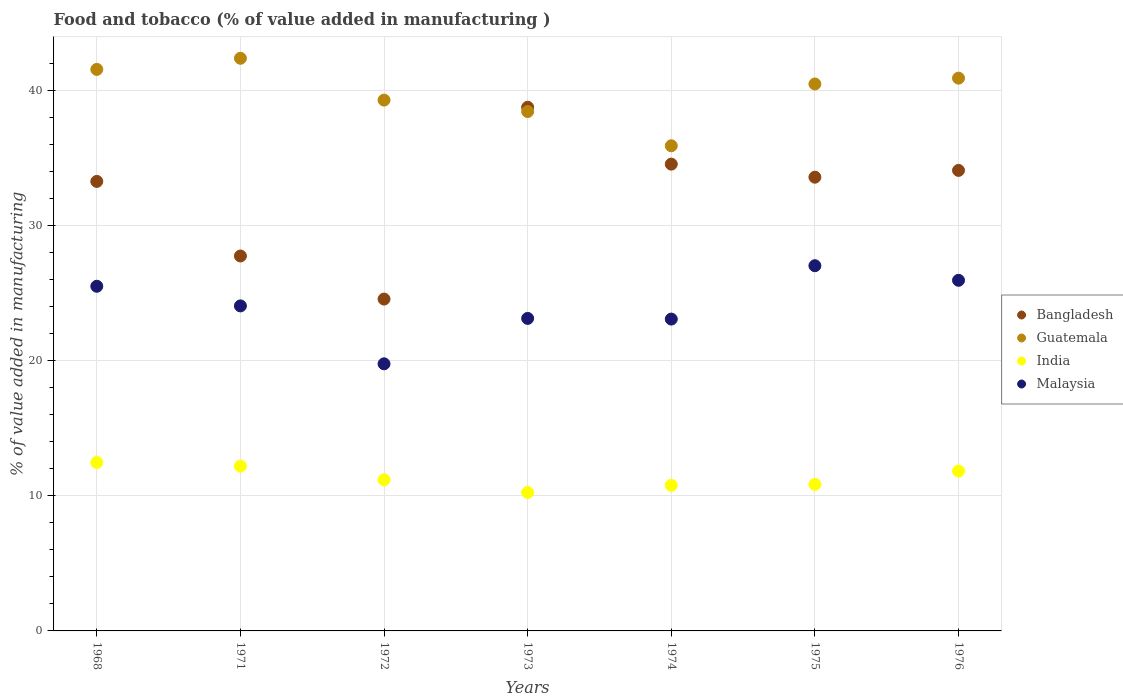Is the number of dotlines equal to the number of legend labels?
Offer a very short reply. Yes. What is the value added in manufacturing food and tobacco in Bangladesh in 1971?
Provide a short and direct response. 27.73. Across all years, what is the maximum value added in manufacturing food and tobacco in Malaysia?
Offer a terse response. 27.02. Across all years, what is the minimum value added in manufacturing food and tobacco in Bangladesh?
Provide a succinct answer. 24.55. In which year was the value added in manufacturing food and tobacco in Malaysia maximum?
Your response must be concise. 1975. What is the total value added in manufacturing food and tobacco in India in the graph?
Offer a terse response. 79.52. What is the difference between the value added in manufacturing food and tobacco in India in 1975 and that in 1976?
Ensure brevity in your answer.  -0.99. What is the difference between the value added in manufacturing food and tobacco in India in 1972 and the value added in manufacturing food and tobacco in Bangladesh in 1968?
Ensure brevity in your answer.  -22.07. What is the average value added in manufacturing food and tobacco in Malaysia per year?
Offer a very short reply. 24.06. In the year 1974, what is the difference between the value added in manufacturing food and tobacco in Bangladesh and value added in manufacturing food and tobacco in Malaysia?
Keep it short and to the point. 11.46. What is the ratio of the value added in manufacturing food and tobacco in Guatemala in 1973 to that in 1975?
Offer a very short reply. 0.95. What is the difference between the highest and the second highest value added in manufacturing food and tobacco in Malaysia?
Make the answer very short. 1.08. What is the difference between the highest and the lowest value added in manufacturing food and tobacco in Bangladesh?
Your answer should be very brief. 14.19. In how many years, is the value added in manufacturing food and tobacco in India greater than the average value added in manufacturing food and tobacco in India taken over all years?
Offer a terse response. 3. Is the value added in manufacturing food and tobacco in India strictly greater than the value added in manufacturing food and tobacco in Bangladesh over the years?
Your response must be concise. No. How many years are there in the graph?
Provide a short and direct response. 7. What is the difference between two consecutive major ticks on the Y-axis?
Make the answer very short. 10. How many legend labels are there?
Give a very brief answer. 4. What is the title of the graph?
Make the answer very short. Food and tobacco (% of value added in manufacturing ). Does "European Union" appear as one of the legend labels in the graph?
Your answer should be very brief. No. What is the label or title of the X-axis?
Your response must be concise. Years. What is the label or title of the Y-axis?
Make the answer very short. % of value added in manufacturing. What is the % of value added in manufacturing of Bangladesh in 1968?
Offer a very short reply. 33.25. What is the % of value added in manufacturing of Guatemala in 1968?
Make the answer very short. 41.54. What is the % of value added in manufacturing in India in 1968?
Offer a very short reply. 12.46. What is the % of value added in manufacturing of Malaysia in 1968?
Offer a very short reply. 25.49. What is the % of value added in manufacturing in Bangladesh in 1971?
Your response must be concise. 27.73. What is the % of value added in manufacturing of Guatemala in 1971?
Offer a very short reply. 42.36. What is the % of value added in manufacturing of India in 1971?
Your answer should be very brief. 12.19. What is the % of value added in manufacturing of Malaysia in 1971?
Make the answer very short. 24.04. What is the % of value added in manufacturing of Bangladesh in 1972?
Your answer should be very brief. 24.55. What is the % of value added in manufacturing of Guatemala in 1972?
Offer a very short reply. 39.27. What is the % of value added in manufacturing of India in 1972?
Make the answer very short. 11.18. What is the % of value added in manufacturing of Malaysia in 1972?
Provide a succinct answer. 19.76. What is the % of value added in manufacturing of Bangladesh in 1973?
Your answer should be very brief. 38.74. What is the % of value added in manufacturing of Guatemala in 1973?
Your answer should be very brief. 38.42. What is the % of value added in manufacturing of India in 1973?
Ensure brevity in your answer.  10.25. What is the % of value added in manufacturing in Malaysia in 1973?
Your answer should be compact. 23.12. What is the % of value added in manufacturing in Bangladesh in 1974?
Provide a succinct answer. 34.53. What is the % of value added in manufacturing of Guatemala in 1974?
Make the answer very short. 35.89. What is the % of value added in manufacturing in India in 1974?
Ensure brevity in your answer.  10.77. What is the % of value added in manufacturing of Malaysia in 1974?
Keep it short and to the point. 23.07. What is the % of value added in manufacturing of Bangladesh in 1975?
Your answer should be very brief. 33.56. What is the % of value added in manufacturing of Guatemala in 1975?
Your answer should be very brief. 40.46. What is the % of value added in manufacturing in India in 1975?
Offer a terse response. 10.84. What is the % of value added in manufacturing in Malaysia in 1975?
Your answer should be very brief. 27.02. What is the % of value added in manufacturing of Bangladesh in 1976?
Your response must be concise. 34.07. What is the % of value added in manufacturing in Guatemala in 1976?
Your response must be concise. 40.89. What is the % of value added in manufacturing of India in 1976?
Provide a succinct answer. 11.83. What is the % of value added in manufacturing of Malaysia in 1976?
Keep it short and to the point. 25.94. Across all years, what is the maximum % of value added in manufacturing in Bangladesh?
Ensure brevity in your answer.  38.74. Across all years, what is the maximum % of value added in manufacturing of Guatemala?
Ensure brevity in your answer.  42.36. Across all years, what is the maximum % of value added in manufacturing in India?
Offer a terse response. 12.46. Across all years, what is the maximum % of value added in manufacturing in Malaysia?
Keep it short and to the point. 27.02. Across all years, what is the minimum % of value added in manufacturing in Bangladesh?
Your answer should be compact. 24.55. Across all years, what is the minimum % of value added in manufacturing in Guatemala?
Provide a succinct answer. 35.89. Across all years, what is the minimum % of value added in manufacturing of India?
Ensure brevity in your answer.  10.25. Across all years, what is the minimum % of value added in manufacturing in Malaysia?
Give a very brief answer. 19.76. What is the total % of value added in manufacturing in Bangladesh in the graph?
Your answer should be very brief. 226.43. What is the total % of value added in manufacturing of Guatemala in the graph?
Offer a terse response. 278.82. What is the total % of value added in manufacturing in India in the graph?
Ensure brevity in your answer.  79.52. What is the total % of value added in manufacturing in Malaysia in the graph?
Offer a terse response. 168.43. What is the difference between the % of value added in manufacturing of Bangladesh in 1968 and that in 1971?
Your response must be concise. 5.52. What is the difference between the % of value added in manufacturing of Guatemala in 1968 and that in 1971?
Make the answer very short. -0.82. What is the difference between the % of value added in manufacturing in India in 1968 and that in 1971?
Make the answer very short. 0.27. What is the difference between the % of value added in manufacturing of Malaysia in 1968 and that in 1971?
Make the answer very short. 1.45. What is the difference between the % of value added in manufacturing of Bangladesh in 1968 and that in 1972?
Offer a very short reply. 8.7. What is the difference between the % of value added in manufacturing of Guatemala in 1968 and that in 1972?
Provide a short and direct response. 2.27. What is the difference between the % of value added in manufacturing in India in 1968 and that in 1972?
Give a very brief answer. 1.28. What is the difference between the % of value added in manufacturing in Malaysia in 1968 and that in 1972?
Offer a terse response. 5.74. What is the difference between the % of value added in manufacturing in Bangladesh in 1968 and that in 1973?
Offer a very short reply. -5.48. What is the difference between the % of value added in manufacturing in Guatemala in 1968 and that in 1973?
Provide a succinct answer. 3.12. What is the difference between the % of value added in manufacturing in India in 1968 and that in 1973?
Make the answer very short. 2.21. What is the difference between the % of value added in manufacturing in Malaysia in 1968 and that in 1973?
Give a very brief answer. 2.38. What is the difference between the % of value added in manufacturing of Bangladesh in 1968 and that in 1974?
Your answer should be compact. -1.28. What is the difference between the % of value added in manufacturing in Guatemala in 1968 and that in 1974?
Your response must be concise. 5.65. What is the difference between the % of value added in manufacturing of India in 1968 and that in 1974?
Ensure brevity in your answer.  1.69. What is the difference between the % of value added in manufacturing in Malaysia in 1968 and that in 1974?
Ensure brevity in your answer.  2.43. What is the difference between the % of value added in manufacturing in Bangladesh in 1968 and that in 1975?
Your answer should be very brief. -0.31. What is the difference between the % of value added in manufacturing of Guatemala in 1968 and that in 1975?
Provide a succinct answer. 1.08. What is the difference between the % of value added in manufacturing of India in 1968 and that in 1975?
Ensure brevity in your answer.  1.62. What is the difference between the % of value added in manufacturing in Malaysia in 1968 and that in 1975?
Provide a succinct answer. -1.52. What is the difference between the % of value added in manufacturing in Bangladesh in 1968 and that in 1976?
Offer a very short reply. -0.82. What is the difference between the % of value added in manufacturing in Guatemala in 1968 and that in 1976?
Your answer should be very brief. 0.65. What is the difference between the % of value added in manufacturing in India in 1968 and that in 1976?
Provide a short and direct response. 0.63. What is the difference between the % of value added in manufacturing of Malaysia in 1968 and that in 1976?
Offer a terse response. -0.44. What is the difference between the % of value added in manufacturing in Bangladesh in 1971 and that in 1972?
Your response must be concise. 3.19. What is the difference between the % of value added in manufacturing of Guatemala in 1971 and that in 1972?
Ensure brevity in your answer.  3.09. What is the difference between the % of value added in manufacturing of India in 1971 and that in 1972?
Your answer should be compact. 1.01. What is the difference between the % of value added in manufacturing in Malaysia in 1971 and that in 1972?
Your response must be concise. 4.28. What is the difference between the % of value added in manufacturing in Bangladesh in 1971 and that in 1973?
Make the answer very short. -11. What is the difference between the % of value added in manufacturing of Guatemala in 1971 and that in 1973?
Keep it short and to the point. 3.94. What is the difference between the % of value added in manufacturing in India in 1971 and that in 1973?
Keep it short and to the point. 1.95. What is the difference between the % of value added in manufacturing of Malaysia in 1971 and that in 1973?
Make the answer very short. 0.93. What is the difference between the % of value added in manufacturing in Bangladesh in 1971 and that in 1974?
Offer a terse response. -6.8. What is the difference between the % of value added in manufacturing in Guatemala in 1971 and that in 1974?
Provide a short and direct response. 6.47. What is the difference between the % of value added in manufacturing in India in 1971 and that in 1974?
Your answer should be very brief. 1.42. What is the difference between the % of value added in manufacturing of Malaysia in 1971 and that in 1974?
Keep it short and to the point. 0.97. What is the difference between the % of value added in manufacturing in Bangladesh in 1971 and that in 1975?
Provide a succinct answer. -5.83. What is the difference between the % of value added in manufacturing of Guatemala in 1971 and that in 1975?
Offer a very short reply. 1.9. What is the difference between the % of value added in manufacturing of India in 1971 and that in 1975?
Give a very brief answer. 1.35. What is the difference between the % of value added in manufacturing of Malaysia in 1971 and that in 1975?
Offer a very short reply. -2.97. What is the difference between the % of value added in manufacturing in Bangladesh in 1971 and that in 1976?
Provide a short and direct response. -6.33. What is the difference between the % of value added in manufacturing in Guatemala in 1971 and that in 1976?
Offer a very short reply. 1.47. What is the difference between the % of value added in manufacturing of India in 1971 and that in 1976?
Your answer should be compact. 0.37. What is the difference between the % of value added in manufacturing in Malaysia in 1971 and that in 1976?
Your answer should be very brief. -1.89. What is the difference between the % of value added in manufacturing of Bangladesh in 1972 and that in 1973?
Provide a succinct answer. -14.19. What is the difference between the % of value added in manufacturing in Guatemala in 1972 and that in 1973?
Ensure brevity in your answer.  0.85. What is the difference between the % of value added in manufacturing in India in 1972 and that in 1973?
Keep it short and to the point. 0.94. What is the difference between the % of value added in manufacturing of Malaysia in 1972 and that in 1973?
Your answer should be compact. -3.36. What is the difference between the % of value added in manufacturing in Bangladesh in 1972 and that in 1974?
Give a very brief answer. -9.98. What is the difference between the % of value added in manufacturing of Guatemala in 1972 and that in 1974?
Your answer should be very brief. 3.38. What is the difference between the % of value added in manufacturing of India in 1972 and that in 1974?
Provide a short and direct response. 0.41. What is the difference between the % of value added in manufacturing in Malaysia in 1972 and that in 1974?
Your answer should be compact. -3.31. What is the difference between the % of value added in manufacturing of Bangladesh in 1972 and that in 1975?
Give a very brief answer. -9.02. What is the difference between the % of value added in manufacturing in Guatemala in 1972 and that in 1975?
Provide a short and direct response. -1.19. What is the difference between the % of value added in manufacturing of India in 1972 and that in 1975?
Make the answer very short. 0.34. What is the difference between the % of value added in manufacturing in Malaysia in 1972 and that in 1975?
Offer a terse response. -7.26. What is the difference between the % of value added in manufacturing in Bangladesh in 1972 and that in 1976?
Keep it short and to the point. -9.52. What is the difference between the % of value added in manufacturing of Guatemala in 1972 and that in 1976?
Your response must be concise. -1.62. What is the difference between the % of value added in manufacturing of India in 1972 and that in 1976?
Provide a succinct answer. -0.65. What is the difference between the % of value added in manufacturing of Malaysia in 1972 and that in 1976?
Give a very brief answer. -6.18. What is the difference between the % of value added in manufacturing of Bangladesh in 1973 and that in 1974?
Ensure brevity in your answer.  4.21. What is the difference between the % of value added in manufacturing of Guatemala in 1973 and that in 1974?
Offer a very short reply. 2.53. What is the difference between the % of value added in manufacturing in India in 1973 and that in 1974?
Your answer should be compact. -0.52. What is the difference between the % of value added in manufacturing of Malaysia in 1973 and that in 1974?
Keep it short and to the point. 0.05. What is the difference between the % of value added in manufacturing of Bangladesh in 1973 and that in 1975?
Offer a very short reply. 5.17. What is the difference between the % of value added in manufacturing of Guatemala in 1973 and that in 1975?
Your answer should be very brief. -2.04. What is the difference between the % of value added in manufacturing of India in 1973 and that in 1975?
Give a very brief answer. -0.59. What is the difference between the % of value added in manufacturing in Malaysia in 1973 and that in 1975?
Provide a short and direct response. -3.9. What is the difference between the % of value added in manufacturing in Bangladesh in 1973 and that in 1976?
Offer a terse response. 4.67. What is the difference between the % of value added in manufacturing in Guatemala in 1973 and that in 1976?
Give a very brief answer. -2.47. What is the difference between the % of value added in manufacturing in India in 1973 and that in 1976?
Offer a terse response. -1.58. What is the difference between the % of value added in manufacturing in Malaysia in 1973 and that in 1976?
Provide a succinct answer. -2.82. What is the difference between the % of value added in manufacturing in Bangladesh in 1974 and that in 1975?
Ensure brevity in your answer.  0.97. What is the difference between the % of value added in manufacturing in Guatemala in 1974 and that in 1975?
Make the answer very short. -4.57. What is the difference between the % of value added in manufacturing of India in 1974 and that in 1975?
Provide a succinct answer. -0.07. What is the difference between the % of value added in manufacturing in Malaysia in 1974 and that in 1975?
Offer a terse response. -3.95. What is the difference between the % of value added in manufacturing of Bangladesh in 1974 and that in 1976?
Ensure brevity in your answer.  0.46. What is the difference between the % of value added in manufacturing in Guatemala in 1974 and that in 1976?
Give a very brief answer. -5. What is the difference between the % of value added in manufacturing in India in 1974 and that in 1976?
Your answer should be compact. -1.06. What is the difference between the % of value added in manufacturing in Malaysia in 1974 and that in 1976?
Offer a terse response. -2.87. What is the difference between the % of value added in manufacturing of Bangladesh in 1975 and that in 1976?
Your answer should be compact. -0.5. What is the difference between the % of value added in manufacturing in Guatemala in 1975 and that in 1976?
Your answer should be very brief. -0.43. What is the difference between the % of value added in manufacturing in India in 1975 and that in 1976?
Your answer should be compact. -0.99. What is the difference between the % of value added in manufacturing in Malaysia in 1975 and that in 1976?
Your answer should be compact. 1.08. What is the difference between the % of value added in manufacturing in Bangladesh in 1968 and the % of value added in manufacturing in Guatemala in 1971?
Offer a very short reply. -9.11. What is the difference between the % of value added in manufacturing in Bangladesh in 1968 and the % of value added in manufacturing in India in 1971?
Offer a very short reply. 21.06. What is the difference between the % of value added in manufacturing in Bangladesh in 1968 and the % of value added in manufacturing in Malaysia in 1971?
Your response must be concise. 9.21. What is the difference between the % of value added in manufacturing of Guatemala in 1968 and the % of value added in manufacturing of India in 1971?
Provide a short and direct response. 29.34. What is the difference between the % of value added in manufacturing in Guatemala in 1968 and the % of value added in manufacturing in Malaysia in 1971?
Offer a terse response. 17.49. What is the difference between the % of value added in manufacturing of India in 1968 and the % of value added in manufacturing of Malaysia in 1971?
Your answer should be compact. -11.58. What is the difference between the % of value added in manufacturing of Bangladesh in 1968 and the % of value added in manufacturing of Guatemala in 1972?
Provide a short and direct response. -6.01. What is the difference between the % of value added in manufacturing of Bangladesh in 1968 and the % of value added in manufacturing of India in 1972?
Make the answer very short. 22.07. What is the difference between the % of value added in manufacturing in Bangladesh in 1968 and the % of value added in manufacturing in Malaysia in 1972?
Offer a very short reply. 13.49. What is the difference between the % of value added in manufacturing of Guatemala in 1968 and the % of value added in manufacturing of India in 1972?
Your answer should be compact. 30.36. What is the difference between the % of value added in manufacturing of Guatemala in 1968 and the % of value added in manufacturing of Malaysia in 1972?
Provide a succinct answer. 21.78. What is the difference between the % of value added in manufacturing of India in 1968 and the % of value added in manufacturing of Malaysia in 1972?
Offer a very short reply. -7.3. What is the difference between the % of value added in manufacturing in Bangladesh in 1968 and the % of value added in manufacturing in Guatemala in 1973?
Offer a terse response. -5.17. What is the difference between the % of value added in manufacturing of Bangladesh in 1968 and the % of value added in manufacturing of India in 1973?
Keep it short and to the point. 23.01. What is the difference between the % of value added in manufacturing of Bangladesh in 1968 and the % of value added in manufacturing of Malaysia in 1973?
Provide a succinct answer. 10.13. What is the difference between the % of value added in manufacturing of Guatemala in 1968 and the % of value added in manufacturing of India in 1973?
Provide a short and direct response. 31.29. What is the difference between the % of value added in manufacturing in Guatemala in 1968 and the % of value added in manufacturing in Malaysia in 1973?
Make the answer very short. 18.42. What is the difference between the % of value added in manufacturing in India in 1968 and the % of value added in manufacturing in Malaysia in 1973?
Provide a succinct answer. -10.66. What is the difference between the % of value added in manufacturing in Bangladesh in 1968 and the % of value added in manufacturing in Guatemala in 1974?
Your answer should be very brief. -2.64. What is the difference between the % of value added in manufacturing of Bangladesh in 1968 and the % of value added in manufacturing of India in 1974?
Give a very brief answer. 22.48. What is the difference between the % of value added in manufacturing of Bangladesh in 1968 and the % of value added in manufacturing of Malaysia in 1974?
Offer a very short reply. 10.18. What is the difference between the % of value added in manufacturing of Guatemala in 1968 and the % of value added in manufacturing of India in 1974?
Provide a short and direct response. 30.77. What is the difference between the % of value added in manufacturing of Guatemala in 1968 and the % of value added in manufacturing of Malaysia in 1974?
Offer a terse response. 18.47. What is the difference between the % of value added in manufacturing in India in 1968 and the % of value added in manufacturing in Malaysia in 1974?
Your response must be concise. -10.61. What is the difference between the % of value added in manufacturing in Bangladesh in 1968 and the % of value added in manufacturing in Guatemala in 1975?
Make the answer very short. -7.21. What is the difference between the % of value added in manufacturing in Bangladesh in 1968 and the % of value added in manufacturing in India in 1975?
Your response must be concise. 22.41. What is the difference between the % of value added in manufacturing of Bangladesh in 1968 and the % of value added in manufacturing of Malaysia in 1975?
Keep it short and to the point. 6.24. What is the difference between the % of value added in manufacturing in Guatemala in 1968 and the % of value added in manufacturing in India in 1975?
Provide a short and direct response. 30.7. What is the difference between the % of value added in manufacturing of Guatemala in 1968 and the % of value added in manufacturing of Malaysia in 1975?
Ensure brevity in your answer.  14.52. What is the difference between the % of value added in manufacturing of India in 1968 and the % of value added in manufacturing of Malaysia in 1975?
Your answer should be compact. -14.56. What is the difference between the % of value added in manufacturing in Bangladesh in 1968 and the % of value added in manufacturing in Guatemala in 1976?
Make the answer very short. -7.64. What is the difference between the % of value added in manufacturing in Bangladesh in 1968 and the % of value added in manufacturing in India in 1976?
Your response must be concise. 21.42. What is the difference between the % of value added in manufacturing of Bangladesh in 1968 and the % of value added in manufacturing of Malaysia in 1976?
Offer a very short reply. 7.31. What is the difference between the % of value added in manufacturing of Guatemala in 1968 and the % of value added in manufacturing of India in 1976?
Give a very brief answer. 29.71. What is the difference between the % of value added in manufacturing in Guatemala in 1968 and the % of value added in manufacturing in Malaysia in 1976?
Your answer should be very brief. 15.6. What is the difference between the % of value added in manufacturing in India in 1968 and the % of value added in manufacturing in Malaysia in 1976?
Provide a short and direct response. -13.48. What is the difference between the % of value added in manufacturing in Bangladesh in 1971 and the % of value added in manufacturing in Guatemala in 1972?
Offer a terse response. -11.53. What is the difference between the % of value added in manufacturing in Bangladesh in 1971 and the % of value added in manufacturing in India in 1972?
Ensure brevity in your answer.  16.55. What is the difference between the % of value added in manufacturing of Bangladesh in 1971 and the % of value added in manufacturing of Malaysia in 1972?
Ensure brevity in your answer.  7.98. What is the difference between the % of value added in manufacturing of Guatemala in 1971 and the % of value added in manufacturing of India in 1972?
Offer a very short reply. 31.18. What is the difference between the % of value added in manufacturing of Guatemala in 1971 and the % of value added in manufacturing of Malaysia in 1972?
Offer a terse response. 22.6. What is the difference between the % of value added in manufacturing of India in 1971 and the % of value added in manufacturing of Malaysia in 1972?
Provide a succinct answer. -7.57. What is the difference between the % of value added in manufacturing of Bangladesh in 1971 and the % of value added in manufacturing of Guatemala in 1973?
Offer a very short reply. -10.69. What is the difference between the % of value added in manufacturing in Bangladesh in 1971 and the % of value added in manufacturing in India in 1973?
Offer a very short reply. 17.49. What is the difference between the % of value added in manufacturing of Bangladesh in 1971 and the % of value added in manufacturing of Malaysia in 1973?
Give a very brief answer. 4.62. What is the difference between the % of value added in manufacturing of Guatemala in 1971 and the % of value added in manufacturing of India in 1973?
Ensure brevity in your answer.  32.11. What is the difference between the % of value added in manufacturing of Guatemala in 1971 and the % of value added in manufacturing of Malaysia in 1973?
Make the answer very short. 19.24. What is the difference between the % of value added in manufacturing of India in 1971 and the % of value added in manufacturing of Malaysia in 1973?
Give a very brief answer. -10.92. What is the difference between the % of value added in manufacturing in Bangladesh in 1971 and the % of value added in manufacturing in Guatemala in 1974?
Provide a short and direct response. -8.15. What is the difference between the % of value added in manufacturing in Bangladesh in 1971 and the % of value added in manufacturing in India in 1974?
Offer a terse response. 16.96. What is the difference between the % of value added in manufacturing in Bangladesh in 1971 and the % of value added in manufacturing in Malaysia in 1974?
Give a very brief answer. 4.67. What is the difference between the % of value added in manufacturing in Guatemala in 1971 and the % of value added in manufacturing in India in 1974?
Give a very brief answer. 31.59. What is the difference between the % of value added in manufacturing in Guatemala in 1971 and the % of value added in manufacturing in Malaysia in 1974?
Your response must be concise. 19.29. What is the difference between the % of value added in manufacturing in India in 1971 and the % of value added in manufacturing in Malaysia in 1974?
Your response must be concise. -10.88. What is the difference between the % of value added in manufacturing in Bangladesh in 1971 and the % of value added in manufacturing in Guatemala in 1975?
Offer a terse response. -12.72. What is the difference between the % of value added in manufacturing of Bangladesh in 1971 and the % of value added in manufacturing of India in 1975?
Keep it short and to the point. 16.89. What is the difference between the % of value added in manufacturing in Bangladesh in 1971 and the % of value added in manufacturing in Malaysia in 1975?
Give a very brief answer. 0.72. What is the difference between the % of value added in manufacturing in Guatemala in 1971 and the % of value added in manufacturing in India in 1975?
Give a very brief answer. 31.52. What is the difference between the % of value added in manufacturing of Guatemala in 1971 and the % of value added in manufacturing of Malaysia in 1975?
Provide a succinct answer. 15.34. What is the difference between the % of value added in manufacturing of India in 1971 and the % of value added in manufacturing of Malaysia in 1975?
Offer a terse response. -14.82. What is the difference between the % of value added in manufacturing of Bangladesh in 1971 and the % of value added in manufacturing of Guatemala in 1976?
Ensure brevity in your answer.  -13.16. What is the difference between the % of value added in manufacturing of Bangladesh in 1971 and the % of value added in manufacturing of India in 1976?
Offer a very short reply. 15.91. What is the difference between the % of value added in manufacturing in Bangladesh in 1971 and the % of value added in manufacturing in Malaysia in 1976?
Provide a short and direct response. 1.8. What is the difference between the % of value added in manufacturing in Guatemala in 1971 and the % of value added in manufacturing in India in 1976?
Give a very brief answer. 30.53. What is the difference between the % of value added in manufacturing of Guatemala in 1971 and the % of value added in manufacturing of Malaysia in 1976?
Your answer should be very brief. 16.42. What is the difference between the % of value added in manufacturing in India in 1971 and the % of value added in manufacturing in Malaysia in 1976?
Your answer should be compact. -13.74. What is the difference between the % of value added in manufacturing of Bangladesh in 1972 and the % of value added in manufacturing of Guatemala in 1973?
Ensure brevity in your answer.  -13.87. What is the difference between the % of value added in manufacturing of Bangladesh in 1972 and the % of value added in manufacturing of India in 1973?
Keep it short and to the point. 14.3. What is the difference between the % of value added in manufacturing in Bangladesh in 1972 and the % of value added in manufacturing in Malaysia in 1973?
Provide a succinct answer. 1.43. What is the difference between the % of value added in manufacturing in Guatemala in 1972 and the % of value added in manufacturing in India in 1973?
Your answer should be very brief. 29.02. What is the difference between the % of value added in manufacturing of Guatemala in 1972 and the % of value added in manufacturing of Malaysia in 1973?
Make the answer very short. 16.15. What is the difference between the % of value added in manufacturing of India in 1972 and the % of value added in manufacturing of Malaysia in 1973?
Your answer should be compact. -11.94. What is the difference between the % of value added in manufacturing in Bangladesh in 1972 and the % of value added in manufacturing in Guatemala in 1974?
Ensure brevity in your answer.  -11.34. What is the difference between the % of value added in manufacturing in Bangladesh in 1972 and the % of value added in manufacturing in India in 1974?
Offer a terse response. 13.78. What is the difference between the % of value added in manufacturing of Bangladesh in 1972 and the % of value added in manufacturing of Malaysia in 1974?
Make the answer very short. 1.48. What is the difference between the % of value added in manufacturing of Guatemala in 1972 and the % of value added in manufacturing of India in 1974?
Offer a very short reply. 28.5. What is the difference between the % of value added in manufacturing of Guatemala in 1972 and the % of value added in manufacturing of Malaysia in 1974?
Provide a short and direct response. 16.2. What is the difference between the % of value added in manufacturing of India in 1972 and the % of value added in manufacturing of Malaysia in 1974?
Provide a succinct answer. -11.89. What is the difference between the % of value added in manufacturing of Bangladesh in 1972 and the % of value added in manufacturing of Guatemala in 1975?
Your answer should be very brief. -15.91. What is the difference between the % of value added in manufacturing in Bangladesh in 1972 and the % of value added in manufacturing in India in 1975?
Make the answer very short. 13.71. What is the difference between the % of value added in manufacturing in Bangladesh in 1972 and the % of value added in manufacturing in Malaysia in 1975?
Your answer should be very brief. -2.47. What is the difference between the % of value added in manufacturing in Guatemala in 1972 and the % of value added in manufacturing in India in 1975?
Offer a terse response. 28.43. What is the difference between the % of value added in manufacturing in Guatemala in 1972 and the % of value added in manufacturing in Malaysia in 1975?
Give a very brief answer. 12.25. What is the difference between the % of value added in manufacturing of India in 1972 and the % of value added in manufacturing of Malaysia in 1975?
Your answer should be compact. -15.83. What is the difference between the % of value added in manufacturing in Bangladesh in 1972 and the % of value added in manufacturing in Guatemala in 1976?
Your response must be concise. -16.34. What is the difference between the % of value added in manufacturing in Bangladesh in 1972 and the % of value added in manufacturing in India in 1976?
Your response must be concise. 12.72. What is the difference between the % of value added in manufacturing of Bangladesh in 1972 and the % of value added in manufacturing of Malaysia in 1976?
Make the answer very short. -1.39. What is the difference between the % of value added in manufacturing in Guatemala in 1972 and the % of value added in manufacturing in India in 1976?
Your answer should be compact. 27.44. What is the difference between the % of value added in manufacturing in Guatemala in 1972 and the % of value added in manufacturing in Malaysia in 1976?
Make the answer very short. 13.33. What is the difference between the % of value added in manufacturing in India in 1972 and the % of value added in manufacturing in Malaysia in 1976?
Your response must be concise. -14.76. What is the difference between the % of value added in manufacturing in Bangladesh in 1973 and the % of value added in manufacturing in Guatemala in 1974?
Offer a very short reply. 2.85. What is the difference between the % of value added in manufacturing of Bangladesh in 1973 and the % of value added in manufacturing of India in 1974?
Offer a terse response. 27.96. What is the difference between the % of value added in manufacturing of Bangladesh in 1973 and the % of value added in manufacturing of Malaysia in 1974?
Offer a very short reply. 15.67. What is the difference between the % of value added in manufacturing of Guatemala in 1973 and the % of value added in manufacturing of India in 1974?
Offer a terse response. 27.65. What is the difference between the % of value added in manufacturing in Guatemala in 1973 and the % of value added in manufacturing in Malaysia in 1974?
Offer a terse response. 15.35. What is the difference between the % of value added in manufacturing of India in 1973 and the % of value added in manufacturing of Malaysia in 1974?
Your answer should be compact. -12.82. What is the difference between the % of value added in manufacturing of Bangladesh in 1973 and the % of value added in manufacturing of Guatemala in 1975?
Your response must be concise. -1.72. What is the difference between the % of value added in manufacturing in Bangladesh in 1973 and the % of value added in manufacturing in India in 1975?
Offer a very short reply. 27.9. What is the difference between the % of value added in manufacturing of Bangladesh in 1973 and the % of value added in manufacturing of Malaysia in 1975?
Give a very brief answer. 11.72. What is the difference between the % of value added in manufacturing in Guatemala in 1973 and the % of value added in manufacturing in India in 1975?
Offer a very short reply. 27.58. What is the difference between the % of value added in manufacturing in Guatemala in 1973 and the % of value added in manufacturing in Malaysia in 1975?
Offer a very short reply. 11.4. What is the difference between the % of value added in manufacturing of India in 1973 and the % of value added in manufacturing of Malaysia in 1975?
Ensure brevity in your answer.  -16.77. What is the difference between the % of value added in manufacturing in Bangladesh in 1973 and the % of value added in manufacturing in Guatemala in 1976?
Provide a short and direct response. -2.15. What is the difference between the % of value added in manufacturing of Bangladesh in 1973 and the % of value added in manufacturing of India in 1976?
Give a very brief answer. 26.91. What is the difference between the % of value added in manufacturing in Bangladesh in 1973 and the % of value added in manufacturing in Malaysia in 1976?
Provide a short and direct response. 12.8. What is the difference between the % of value added in manufacturing in Guatemala in 1973 and the % of value added in manufacturing in India in 1976?
Make the answer very short. 26.59. What is the difference between the % of value added in manufacturing of Guatemala in 1973 and the % of value added in manufacturing of Malaysia in 1976?
Ensure brevity in your answer.  12.48. What is the difference between the % of value added in manufacturing of India in 1973 and the % of value added in manufacturing of Malaysia in 1976?
Offer a very short reply. -15.69. What is the difference between the % of value added in manufacturing of Bangladesh in 1974 and the % of value added in manufacturing of Guatemala in 1975?
Offer a terse response. -5.93. What is the difference between the % of value added in manufacturing of Bangladesh in 1974 and the % of value added in manufacturing of India in 1975?
Keep it short and to the point. 23.69. What is the difference between the % of value added in manufacturing of Bangladesh in 1974 and the % of value added in manufacturing of Malaysia in 1975?
Keep it short and to the point. 7.51. What is the difference between the % of value added in manufacturing in Guatemala in 1974 and the % of value added in manufacturing in India in 1975?
Your response must be concise. 25.05. What is the difference between the % of value added in manufacturing in Guatemala in 1974 and the % of value added in manufacturing in Malaysia in 1975?
Make the answer very short. 8.87. What is the difference between the % of value added in manufacturing in India in 1974 and the % of value added in manufacturing in Malaysia in 1975?
Give a very brief answer. -16.25. What is the difference between the % of value added in manufacturing of Bangladesh in 1974 and the % of value added in manufacturing of Guatemala in 1976?
Offer a terse response. -6.36. What is the difference between the % of value added in manufacturing of Bangladesh in 1974 and the % of value added in manufacturing of India in 1976?
Keep it short and to the point. 22.7. What is the difference between the % of value added in manufacturing in Bangladesh in 1974 and the % of value added in manufacturing in Malaysia in 1976?
Offer a terse response. 8.59. What is the difference between the % of value added in manufacturing in Guatemala in 1974 and the % of value added in manufacturing in India in 1976?
Give a very brief answer. 24.06. What is the difference between the % of value added in manufacturing of Guatemala in 1974 and the % of value added in manufacturing of Malaysia in 1976?
Provide a short and direct response. 9.95. What is the difference between the % of value added in manufacturing of India in 1974 and the % of value added in manufacturing of Malaysia in 1976?
Your answer should be very brief. -15.17. What is the difference between the % of value added in manufacturing of Bangladesh in 1975 and the % of value added in manufacturing of Guatemala in 1976?
Make the answer very short. -7.33. What is the difference between the % of value added in manufacturing of Bangladesh in 1975 and the % of value added in manufacturing of India in 1976?
Your response must be concise. 21.74. What is the difference between the % of value added in manufacturing in Bangladesh in 1975 and the % of value added in manufacturing in Malaysia in 1976?
Keep it short and to the point. 7.63. What is the difference between the % of value added in manufacturing of Guatemala in 1975 and the % of value added in manufacturing of India in 1976?
Your response must be concise. 28.63. What is the difference between the % of value added in manufacturing of Guatemala in 1975 and the % of value added in manufacturing of Malaysia in 1976?
Keep it short and to the point. 14.52. What is the difference between the % of value added in manufacturing in India in 1975 and the % of value added in manufacturing in Malaysia in 1976?
Your answer should be compact. -15.1. What is the average % of value added in manufacturing in Bangladesh per year?
Keep it short and to the point. 32.35. What is the average % of value added in manufacturing in Guatemala per year?
Provide a succinct answer. 39.83. What is the average % of value added in manufacturing in India per year?
Provide a succinct answer. 11.36. What is the average % of value added in manufacturing of Malaysia per year?
Make the answer very short. 24.06. In the year 1968, what is the difference between the % of value added in manufacturing of Bangladesh and % of value added in manufacturing of Guatemala?
Your response must be concise. -8.29. In the year 1968, what is the difference between the % of value added in manufacturing in Bangladesh and % of value added in manufacturing in India?
Your answer should be very brief. 20.79. In the year 1968, what is the difference between the % of value added in manufacturing of Bangladesh and % of value added in manufacturing of Malaysia?
Your response must be concise. 7.76. In the year 1968, what is the difference between the % of value added in manufacturing in Guatemala and % of value added in manufacturing in India?
Provide a short and direct response. 29.08. In the year 1968, what is the difference between the % of value added in manufacturing of Guatemala and % of value added in manufacturing of Malaysia?
Your answer should be compact. 16.04. In the year 1968, what is the difference between the % of value added in manufacturing in India and % of value added in manufacturing in Malaysia?
Ensure brevity in your answer.  -13.03. In the year 1971, what is the difference between the % of value added in manufacturing of Bangladesh and % of value added in manufacturing of Guatemala?
Your response must be concise. -14.63. In the year 1971, what is the difference between the % of value added in manufacturing in Bangladesh and % of value added in manufacturing in India?
Your answer should be compact. 15.54. In the year 1971, what is the difference between the % of value added in manufacturing in Bangladesh and % of value added in manufacturing in Malaysia?
Ensure brevity in your answer.  3.69. In the year 1971, what is the difference between the % of value added in manufacturing in Guatemala and % of value added in manufacturing in India?
Make the answer very short. 30.17. In the year 1971, what is the difference between the % of value added in manufacturing of Guatemala and % of value added in manufacturing of Malaysia?
Provide a succinct answer. 18.32. In the year 1971, what is the difference between the % of value added in manufacturing of India and % of value added in manufacturing of Malaysia?
Provide a short and direct response. -11.85. In the year 1972, what is the difference between the % of value added in manufacturing of Bangladesh and % of value added in manufacturing of Guatemala?
Keep it short and to the point. -14.72. In the year 1972, what is the difference between the % of value added in manufacturing in Bangladesh and % of value added in manufacturing in India?
Ensure brevity in your answer.  13.37. In the year 1972, what is the difference between the % of value added in manufacturing of Bangladesh and % of value added in manufacturing of Malaysia?
Provide a short and direct response. 4.79. In the year 1972, what is the difference between the % of value added in manufacturing in Guatemala and % of value added in manufacturing in India?
Offer a very short reply. 28.08. In the year 1972, what is the difference between the % of value added in manufacturing in Guatemala and % of value added in manufacturing in Malaysia?
Offer a very short reply. 19.51. In the year 1972, what is the difference between the % of value added in manufacturing in India and % of value added in manufacturing in Malaysia?
Your response must be concise. -8.58. In the year 1973, what is the difference between the % of value added in manufacturing of Bangladesh and % of value added in manufacturing of Guatemala?
Your answer should be compact. 0.31. In the year 1973, what is the difference between the % of value added in manufacturing of Bangladesh and % of value added in manufacturing of India?
Your response must be concise. 28.49. In the year 1973, what is the difference between the % of value added in manufacturing of Bangladesh and % of value added in manufacturing of Malaysia?
Make the answer very short. 15.62. In the year 1973, what is the difference between the % of value added in manufacturing in Guatemala and % of value added in manufacturing in India?
Ensure brevity in your answer.  28.18. In the year 1973, what is the difference between the % of value added in manufacturing in Guatemala and % of value added in manufacturing in Malaysia?
Give a very brief answer. 15.3. In the year 1973, what is the difference between the % of value added in manufacturing of India and % of value added in manufacturing of Malaysia?
Keep it short and to the point. -12.87. In the year 1974, what is the difference between the % of value added in manufacturing in Bangladesh and % of value added in manufacturing in Guatemala?
Your answer should be very brief. -1.36. In the year 1974, what is the difference between the % of value added in manufacturing of Bangladesh and % of value added in manufacturing of India?
Give a very brief answer. 23.76. In the year 1974, what is the difference between the % of value added in manufacturing in Bangladesh and % of value added in manufacturing in Malaysia?
Offer a very short reply. 11.46. In the year 1974, what is the difference between the % of value added in manufacturing of Guatemala and % of value added in manufacturing of India?
Offer a terse response. 25.12. In the year 1974, what is the difference between the % of value added in manufacturing of Guatemala and % of value added in manufacturing of Malaysia?
Keep it short and to the point. 12.82. In the year 1974, what is the difference between the % of value added in manufacturing in India and % of value added in manufacturing in Malaysia?
Provide a succinct answer. -12.3. In the year 1975, what is the difference between the % of value added in manufacturing in Bangladesh and % of value added in manufacturing in Guatemala?
Provide a short and direct response. -6.9. In the year 1975, what is the difference between the % of value added in manufacturing in Bangladesh and % of value added in manufacturing in India?
Offer a very short reply. 22.72. In the year 1975, what is the difference between the % of value added in manufacturing in Bangladesh and % of value added in manufacturing in Malaysia?
Your answer should be compact. 6.55. In the year 1975, what is the difference between the % of value added in manufacturing in Guatemala and % of value added in manufacturing in India?
Your answer should be compact. 29.62. In the year 1975, what is the difference between the % of value added in manufacturing in Guatemala and % of value added in manufacturing in Malaysia?
Offer a very short reply. 13.44. In the year 1975, what is the difference between the % of value added in manufacturing of India and % of value added in manufacturing of Malaysia?
Your response must be concise. -16.18. In the year 1976, what is the difference between the % of value added in manufacturing in Bangladesh and % of value added in manufacturing in Guatemala?
Your answer should be compact. -6.82. In the year 1976, what is the difference between the % of value added in manufacturing of Bangladesh and % of value added in manufacturing of India?
Provide a succinct answer. 22.24. In the year 1976, what is the difference between the % of value added in manufacturing in Bangladesh and % of value added in manufacturing in Malaysia?
Offer a very short reply. 8.13. In the year 1976, what is the difference between the % of value added in manufacturing of Guatemala and % of value added in manufacturing of India?
Your answer should be very brief. 29.06. In the year 1976, what is the difference between the % of value added in manufacturing of Guatemala and % of value added in manufacturing of Malaysia?
Offer a terse response. 14.95. In the year 1976, what is the difference between the % of value added in manufacturing in India and % of value added in manufacturing in Malaysia?
Keep it short and to the point. -14.11. What is the ratio of the % of value added in manufacturing of Bangladesh in 1968 to that in 1971?
Offer a terse response. 1.2. What is the ratio of the % of value added in manufacturing of Guatemala in 1968 to that in 1971?
Give a very brief answer. 0.98. What is the ratio of the % of value added in manufacturing of India in 1968 to that in 1971?
Make the answer very short. 1.02. What is the ratio of the % of value added in manufacturing of Malaysia in 1968 to that in 1971?
Offer a very short reply. 1.06. What is the ratio of the % of value added in manufacturing in Bangladesh in 1968 to that in 1972?
Offer a very short reply. 1.35. What is the ratio of the % of value added in manufacturing of Guatemala in 1968 to that in 1972?
Your answer should be very brief. 1.06. What is the ratio of the % of value added in manufacturing in India in 1968 to that in 1972?
Offer a terse response. 1.11. What is the ratio of the % of value added in manufacturing of Malaysia in 1968 to that in 1972?
Provide a succinct answer. 1.29. What is the ratio of the % of value added in manufacturing of Bangladesh in 1968 to that in 1973?
Offer a very short reply. 0.86. What is the ratio of the % of value added in manufacturing in Guatemala in 1968 to that in 1973?
Ensure brevity in your answer.  1.08. What is the ratio of the % of value added in manufacturing of India in 1968 to that in 1973?
Provide a short and direct response. 1.22. What is the ratio of the % of value added in manufacturing in Malaysia in 1968 to that in 1973?
Offer a very short reply. 1.1. What is the ratio of the % of value added in manufacturing of Guatemala in 1968 to that in 1974?
Offer a terse response. 1.16. What is the ratio of the % of value added in manufacturing of India in 1968 to that in 1974?
Your response must be concise. 1.16. What is the ratio of the % of value added in manufacturing in Malaysia in 1968 to that in 1974?
Keep it short and to the point. 1.11. What is the ratio of the % of value added in manufacturing of Bangladesh in 1968 to that in 1975?
Offer a terse response. 0.99. What is the ratio of the % of value added in manufacturing of Guatemala in 1968 to that in 1975?
Give a very brief answer. 1.03. What is the ratio of the % of value added in manufacturing of India in 1968 to that in 1975?
Provide a succinct answer. 1.15. What is the ratio of the % of value added in manufacturing in Malaysia in 1968 to that in 1975?
Provide a succinct answer. 0.94. What is the ratio of the % of value added in manufacturing in Bangladesh in 1968 to that in 1976?
Provide a short and direct response. 0.98. What is the ratio of the % of value added in manufacturing in Guatemala in 1968 to that in 1976?
Offer a very short reply. 1.02. What is the ratio of the % of value added in manufacturing of India in 1968 to that in 1976?
Your answer should be very brief. 1.05. What is the ratio of the % of value added in manufacturing in Bangladesh in 1971 to that in 1972?
Provide a succinct answer. 1.13. What is the ratio of the % of value added in manufacturing of Guatemala in 1971 to that in 1972?
Provide a succinct answer. 1.08. What is the ratio of the % of value added in manufacturing in India in 1971 to that in 1972?
Provide a succinct answer. 1.09. What is the ratio of the % of value added in manufacturing of Malaysia in 1971 to that in 1972?
Give a very brief answer. 1.22. What is the ratio of the % of value added in manufacturing in Bangladesh in 1971 to that in 1973?
Offer a very short reply. 0.72. What is the ratio of the % of value added in manufacturing in Guatemala in 1971 to that in 1973?
Provide a succinct answer. 1.1. What is the ratio of the % of value added in manufacturing of India in 1971 to that in 1973?
Offer a very short reply. 1.19. What is the ratio of the % of value added in manufacturing in Malaysia in 1971 to that in 1973?
Keep it short and to the point. 1.04. What is the ratio of the % of value added in manufacturing of Bangladesh in 1971 to that in 1974?
Provide a succinct answer. 0.8. What is the ratio of the % of value added in manufacturing in Guatemala in 1971 to that in 1974?
Your answer should be very brief. 1.18. What is the ratio of the % of value added in manufacturing of India in 1971 to that in 1974?
Provide a short and direct response. 1.13. What is the ratio of the % of value added in manufacturing of Malaysia in 1971 to that in 1974?
Your response must be concise. 1.04. What is the ratio of the % of value added in manufacturing of Bangladesh in 1971 to that in 1975?
Offer a very short reply. 0.83. What is the ratio of the % of value added in manufacturing of Guatemala in 1971 to that in 1975?
Give a very brief answer. 1.05. What is the ratio of the % of value added in manufacturing in India in 1971 to that in 1975?
Your answer should be very brief. 1.12. What is the ratio of the % of value added in manufacturing in Malaysia in 1971 to that in 1975?
Offer a very short reply. 0.89. What is the ratio of the % of value added in manufacturing in Bangladesh in 1971 to that in 1976?
Offer a terse response. 0.81. What is the ratio of the % of value added in manufacturing of Guatemala in 1971 to that in 1976?
Your response must be concise. 1.04. What is the ratio of the % of value added in manufacturing of India in 1971 to that in 1976?
Provide a short and direct response. 1.03. What is the ratio of the % of value added in manufacturing in Malaysia in 1971 to that in 1976?
Your answer should be very brief. 0.93. What is the ratio of the % of value added in manufacturing in Bangladesh in 1972 to that in 1973?
Make the answer very short. 0.63. What is the ratio of the % of value added in manufacturing of India in 1972 to that in 1973?
Provide a succinct answer. 1.09. What is the ratio of the % of value added in manufacturing in Malaysia in 1972 to that in 1973?
Your answer should be very brief. 0.85. What is the ratio of the % of value added in manufacturing of Bangladesh in 1972 to that in 1974?
Offer a very short reply. 0.71. What is the ratio of the % of value added in manufacturing of Guatemala in 1972 to that in 1974?
Make the answer very short. 1.09. What is the ratio of the % of value added in manufacturing in India in 1972 to that in 1974?
Your answer should be compact. 1.04. What is the ratio of the % of value added in manufacturing of Malaysia in 1972 to that in 1974?
Give a very brief answer. 0.86. What is the ratio of the % of value added in manufacturing of Bangladesh in 1972 to that in 1975?
Your answer should be very brief. 0.73. What is the ratio of the % of value added in manufacturing of Guatemala in 1972 to that in 1975?
Keep it short and to the point. 0.97. What is the ratio of the % of value added in manufacturing in India in 1972 to that in 1975?
Your answer should be compact. 1.03. What is the ratio of the % of value added in manufacturing in Malaysia in 1972 to that in 1975?
Ensure brevity in your answer.  0.73. What is the ratio of the % of value added in manufacturing in Bangladesh in 1972 to that in 1976?
Provide a succinct answer. 0.72. What is the ratio of the % of value added in manufacturing in Guatemala in 1972 to that in 1976?
Ensure brevity in your answer.  0.96. What is the ratio of the % of value added in manufacturing in India in 1972 to that in 1976?
Ensure brevity in your answer.  0.95. What is the ratio of the % of value added in manufacturing of Malaysia in 1972 to that in 1976?
Keep it short and to the point. 0.76. What is the ratio of the % of value added in manufacturing of Bangladesh in 1973 to that in 1974?
Your answer should be compact. 1.12. What is the ratio of the % of value added in manufacturing in Guatemala in 1973 to that in 1974?
Offer a very short reply. 1.07. What is the ratio of the % of value added in manufacturing in India in 1973 to that in 1974?
Your response must be concise. 0.95. What is the ratio of the % of value added in manufacturing in Bangladesh in 1973 to that in 1975?
Provide a succinct answer. 1.15. What is the ratio of the % of value added in manufacturing in Guatemala in 1973 to that in 1975?
Ensure brevity in your answer.  0.95. What is the ratio of the % of value added in manufacturing of India in 1973 to that in 1975?
Provide a short and direct response. 0.95. What is the ratio of the % of value added in manufacturing of Malaysia in 1973 to that in 1975?
Keep it short and to the point. 0.86. What is the ratio of the % of value added in manufacturing of Bangladesh in 1973 to that in 1976?
Give a very brief answer. 1.14. What is the ratio of the % of value added in manufacturing of Guatemala in 1973 to that in 1976?
Give a very brief answer. 0.94. What is the ratio of the % of value added in manufacturing in India in 1973 to that in 1976?
Your answer should be compact. 0.87. What is the ratio of the % of value added in manufacturing in Malaysia in 1973 to that in 1976?
Make the answer very short. 0.89. What is the ratio of the % of value added in manufacturing of Bangladesh in 1974 to that in 1975?
Give a very brief answer. 1.03. What is the ratio of the % of value added in manufacturing in Guatemala in 1974 to that in 1975?
Offer a terse response. 0.89. What is the ratio of the % of value added in manufacturing in India in 1974 to that in 1975?
Give a very brief answer. 0.99. What is the ratio of the % of value added in manufacturing of Malaysia in 1974 to that in 1975?
Provide a succinct answer. 0.85. What is the ratio of the % of value added in manufacturing in Bangladesh in 1974 to that in 1976?
Your response must be concise. 1.01. What is the ratio of the % of value added in manufacturing in Guatemala in 1974 to that in 1976?
Ensure brevity in your answer.  0.88. What is the ratio of the % of value added in manufacturing of India in 1974 to that in 1976?
Your answer should be compact. 0.91. What is the ratio of the % of value added in manufacturing of Malaysia in 1974 to that in 1976?
Provide a succinct answer. 0.89. What is the ratio of the % of value added in manufacturing in Bangladesh in 1975 to that in 1976?
Keep it short and to the point. 0.99. What is the ratio of the % of value added in manufacturing of Guatemala in 1975 to that in 1976?
Keep it short and to the point. 0.99. What is the ratio of the % of value added in manufacturing in India in 1975 to that in 1976?
Your answer should be compact. 0.92. What is the ratio of the % of value added in manufacturing in Malaysia in 1975 to that in 1976?
Your answer should be compact. 1.04. What is the difference between the highest and the second highest % of value added in manufacturing in Bangladesh?
Your answer should be compact. 4.21. What is the difference between the highest and the second highest % of value added in manufacturing in Guatemala?
Offer a very short reply. 0.82. What is the difference between the highest and the second highest % of value added in manufacturing of India?
Your answer should be compact. 0.27. What is the difference between the highest and the second highest % of value added in manufacturing of Malaysia?
Give a very brief answer. 1.08. What is the difference between the highest and the lowest % of value added in manufacturing of Bangladesh?
Your response must be concise. 14.19. What is the difference between the highest and the lowest % of value added in manufacturing in Guatemala?
Offer a very short reply. 6.47. What is the difference between the highest and the lowest % of value added in manufacturing of India?
Provide a short and direct response. 2.21. What is the difference between the highest and the lowest % of value added in manufacturing of Malaysia?
Your answer should be very brief. 7.26. 